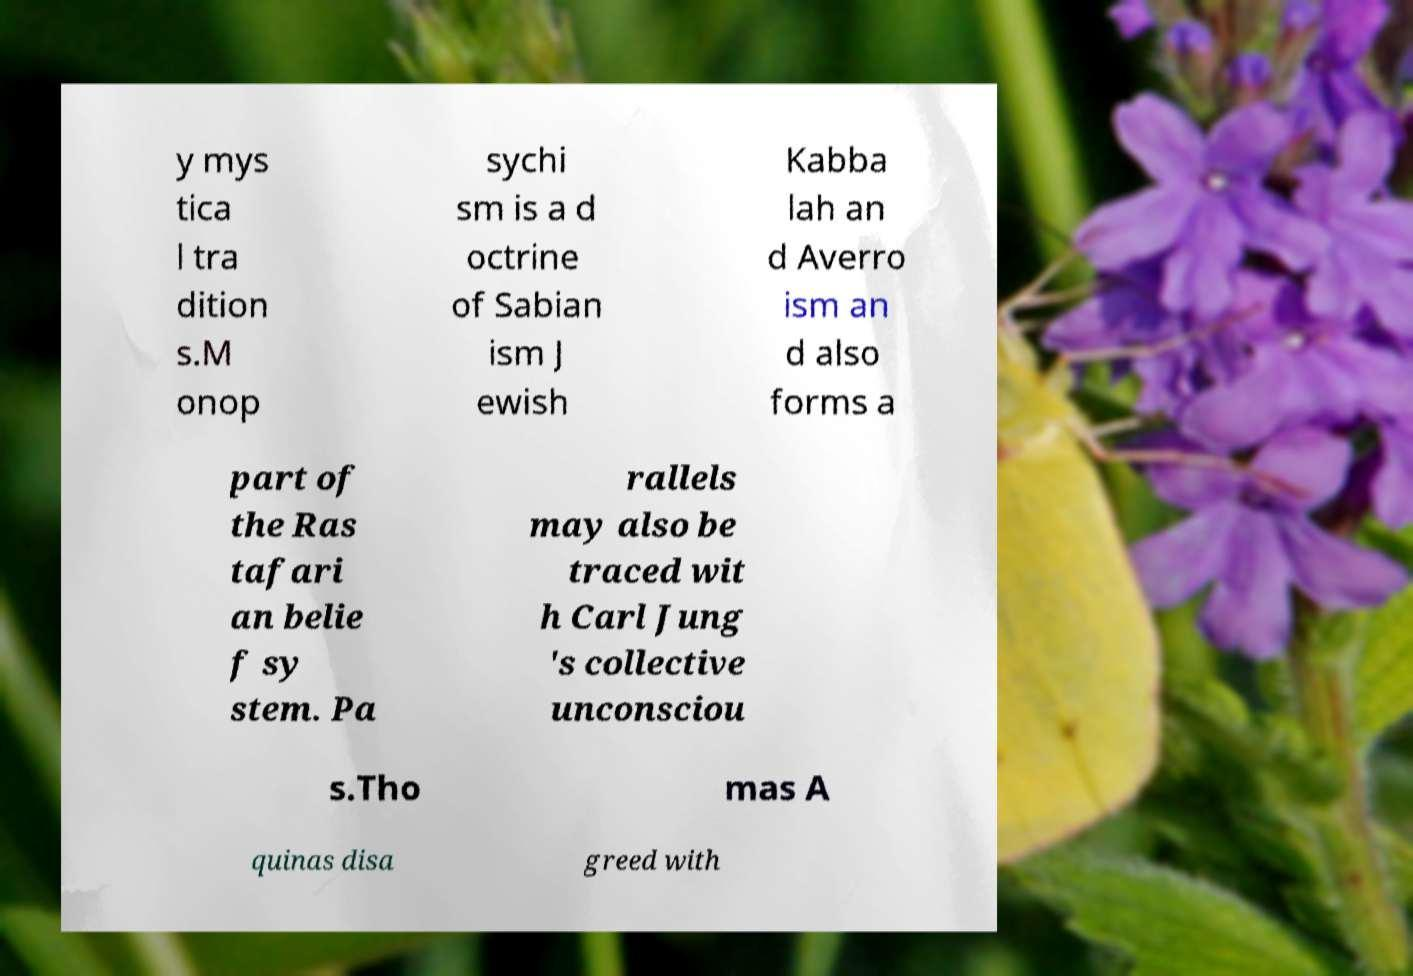Could you extract and type out the text from this image? y mys tica l tra dition s.M onop sychi sm is a d octrine of Sabian ism J ewish Kabba lah an d Averro ism an d also forms a part of the Ras tafari an belie f sy stem. Pa rallels may also be traced wit h Carl Jung 's collective unconsciou s.Tho mas A quinas disa greed with 